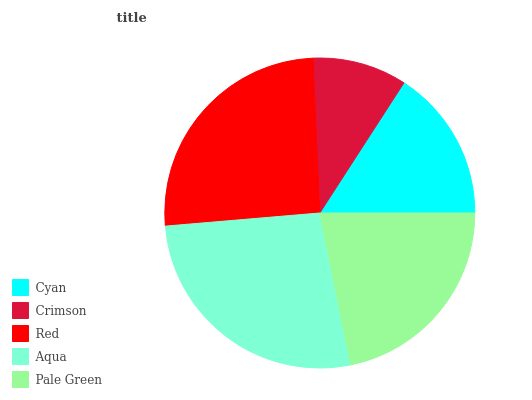Is Crimson the minimum?
Answer yes or no. Yes. Is Aqua the maximum?
Answer yes or no. Yes. Is Red the minimum?
Answer yes or no. No. Is Red the maximum?
Answer yes or no. No. Is Red greater than Crimson?
Answer yes or no. Yes. Is Crimson less than Red?
Answer yes or no. Yes. Is Crimson greater than Red?
Answer yes or no. No. Is Red less than Crimson?
Answer yes or no. No. Is Pale Green the high median?
Answer yes or no. Yes. Is Pale Green the low median?
Answer yes or no. Yes. Is Aqua the high median?
Answer yes or no. No. Is Aqua the low median?
Answer yes or no. No. 